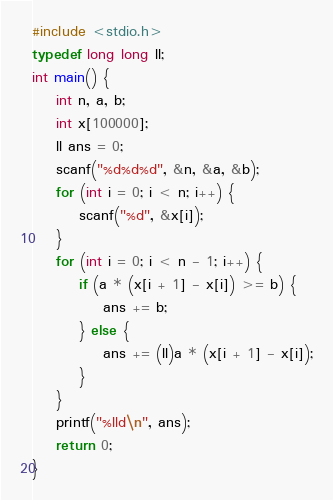Convert code to text. <code><loc_0><loc_0><loc_500><loc_500><_C_>#include <stdio.h>
typedef long long ll;
int main() {
	int n, a, b;
	int x[100000];
	ll ans = 0;
	scanf("%d%d%d", &n, &a, &b);
	for (int i = 0; i < n; i++) {
		scanf("%d", &x[i]);
	}
	for (int i = 0; i < n - 1; i++) {
		if (a * (x[i + 1] - x[i]) >= b) {
			ans += b;
		} else {
			ans += (ll)a * (x[i + 1] - x[i]);
		}
	}
	printf("%lld\n", ans);
	return 0;
}
</code> 